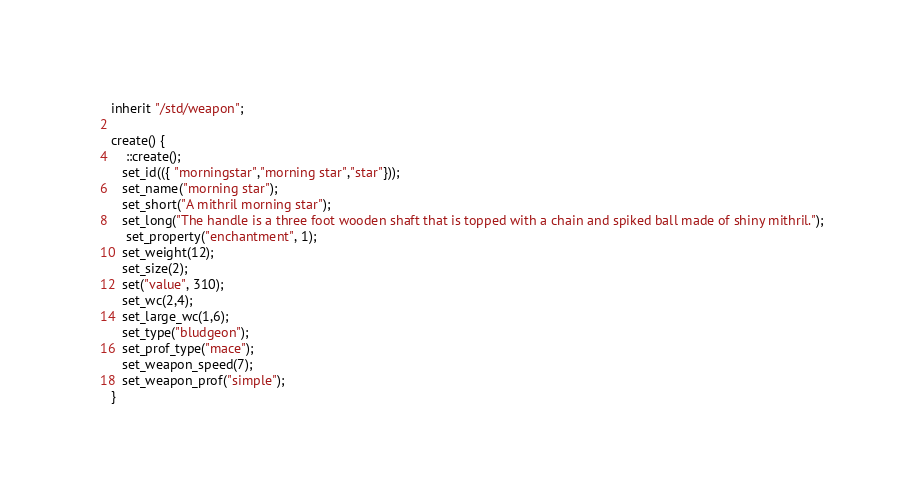<code> <loc_0><loc_0><loc_500><loc_500><_C_>inherit "/std/weapon";

create() {
	::create();
   set_id(({ "morningstar","morning star","star"}));
   set_name("morning star");
   set_short("A mithril morning star");
   set_long("The handle is a three foot wooden shaft that is topped with a chain and spiked ball made of shiny mithril.");
	set_property("enchantment", 1);
   set_weight(12);
   set_size(2);
   set("value", 310);
   set_wc(2,4);
   set_large_wc(1,6);
   set_type("bludgeon");
   set_prof_type("mace");
   set_weapon_speed(7);
   set_weapon_prof("simple");
}
</code> 